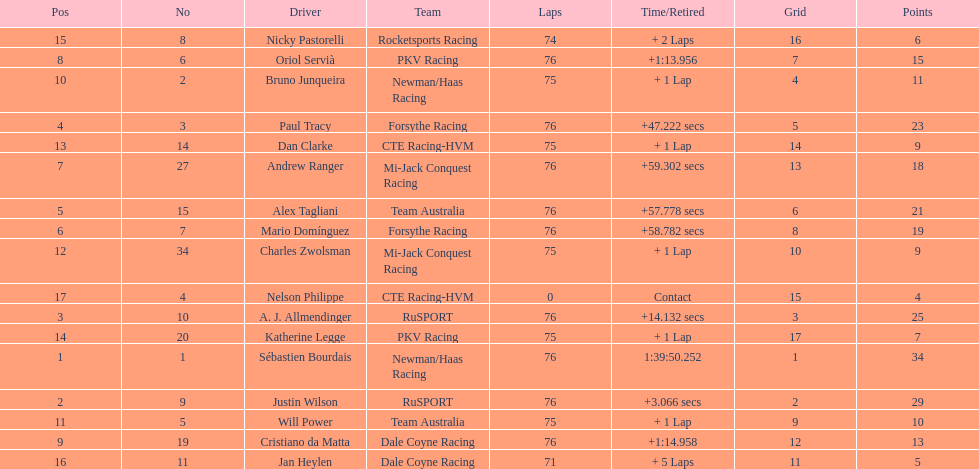What was the total points that canada earned together? 62. 